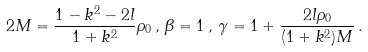<formula> <loc_0><loc_0><loc_500><loc_500>2 M = \frac { 1 - k ^ { 2 } - 2 l } { 1 + k ^ { 2 } } \rho _ { 0 } \, , \, \beta = 1 \, , \, \gamma = 1 + \frac { 2 l \rho _ { 0 } } { ( 1 + k ^ { 2 } ) M } \, .</formula> 